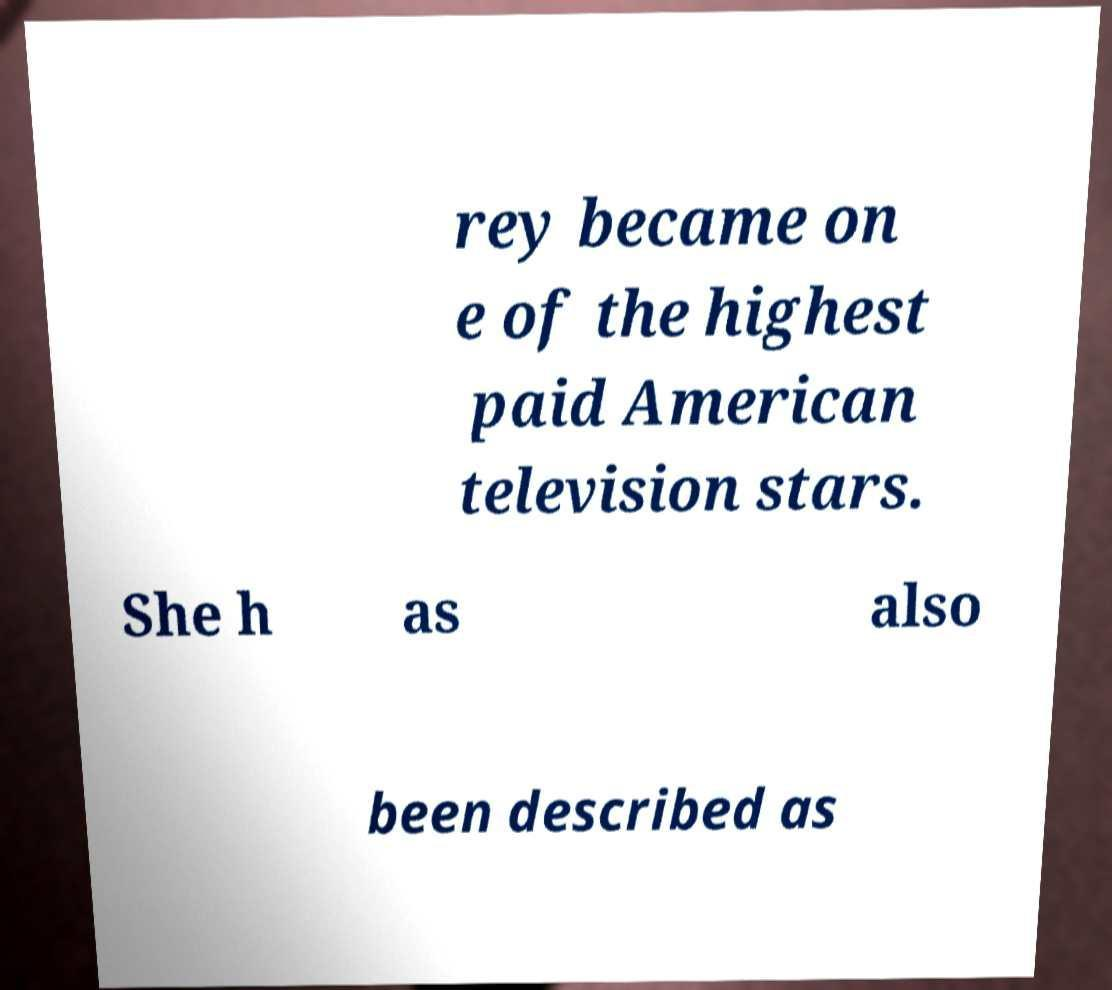Can you accurately transcribe the text from the provided image for me? rey became on e of the highest paid American television stars. She h as also been described as 